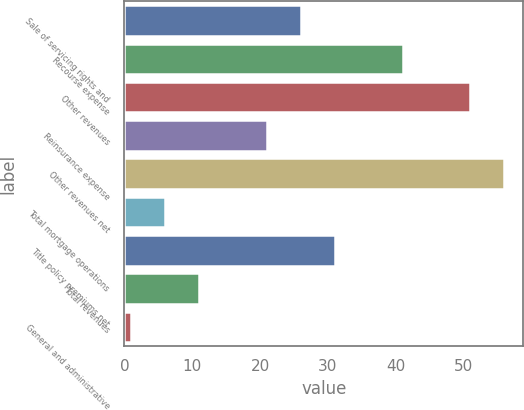Convert chart. <chart><loc_0><loc_0><loc_500><loc_500><bar_chart><fcel>Sale of servicing rights and<fcel>Recourse expense<fcel>Other revenues<fcel>Reinsurance expense<fcel>Other revenues net<fcel>Total mortgage operations<fcel>Title policy premiums net<fcel>Total revenues<fcel>General and administrative<nl><fcel>26<fcel>41<fcel>51<fcel>21<fcel>56<fcel>6<fcel>31<fcel>11<fcel>1<nl></chart> 